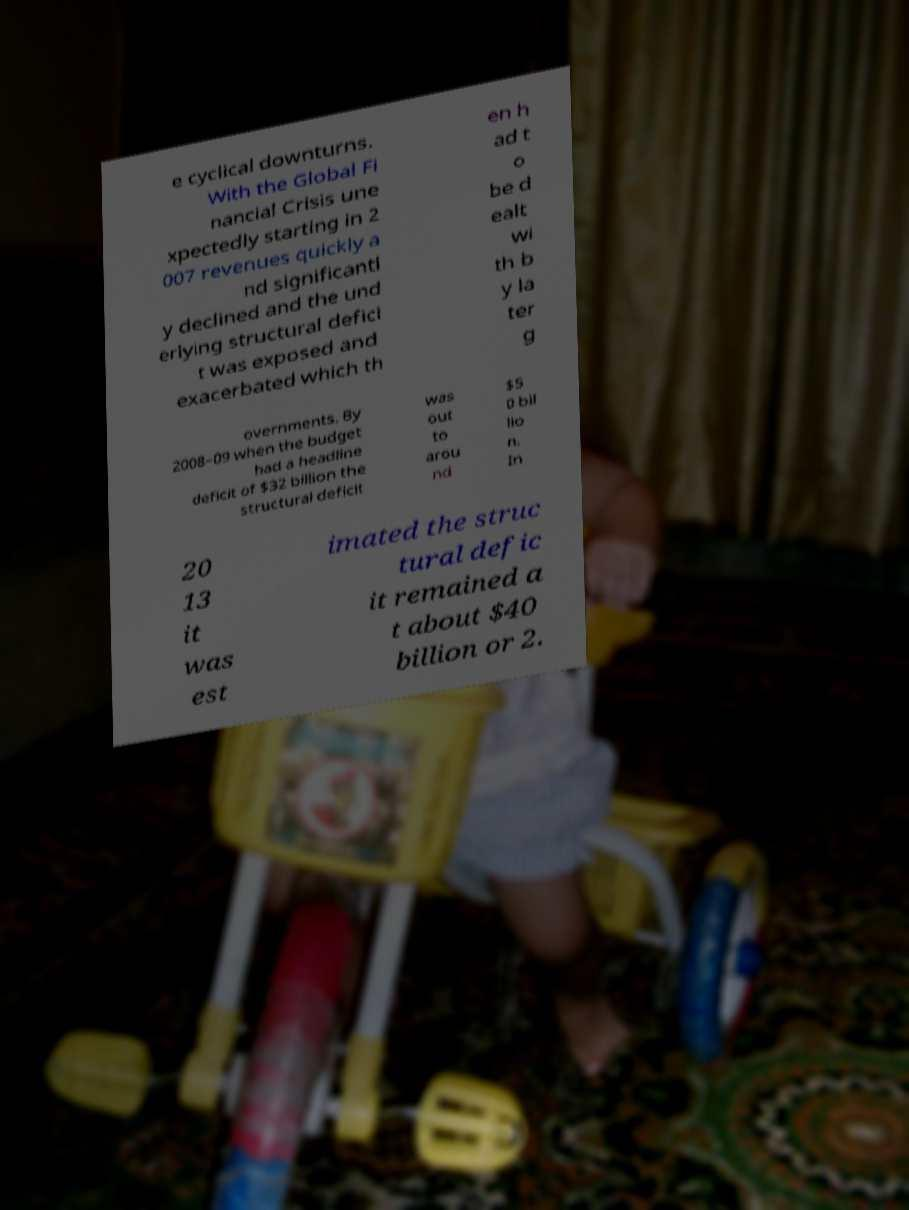Please identify and transcribe the text found in this image. e cyclical downturns. With the Global Fi nancial Crisis une xpectedly starting in 2 007 revenues quickly a nd significantl y declined and the und erlying structural defici t was exposed and exacerbated which th en h ad t o be d ealt wi th b y la ter g overnments. By 2008–09 when the budget had a headline deficit of $32 billion the structural deficit was out to arou nd $5 0 bil lio n. In 20 13 it was est imated the struc tural defic it remained a t about $40 billion or 2. 